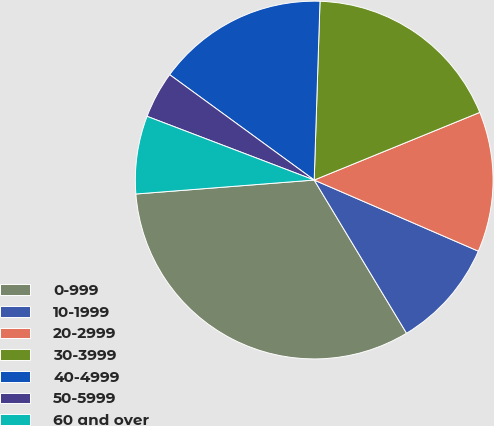Convert chart. <chart><loc_0><loc_0><loc_500><loc_500><pie_chart><fcel>0-999<fcel>10-1999<fcel>20-2999<fcel>30-3999<fcel>40-4999<fcel>50-5999<fcel>60 and over<nl><fcel>32.39%<fcel>9.86%<fcel>12.68%<fcel>18.31%<fcel>15.49%<fcel>4.23%<fcel>7.04%<nl></chart> 